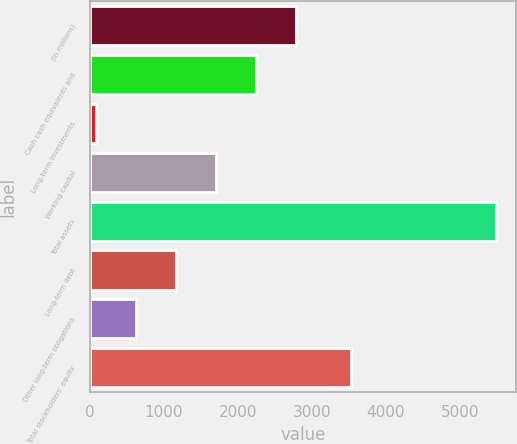Convert chart to OTSL. <chart><loc_0><loc_0><loc_500><loc_500><bar_chart><fcel>(In millions)<fcel>Cash cash equivalents and<fcel>Long-term investments<fcel>Working capital<fcel>Total assets<fcel>Long-term debt<fcel>Other long-term obligations<fcel>Total stockholders' equity<nl><fcel>2784.5<fcel>2244.2<fcel>83<fcel>1703.9<fcel>5486<fcel>1163.6<fcel>623.3<fcel>3531<nl></chart> 